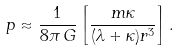<formula> <loc_0><loc_0><loc_500><loc_500>p \approx \frac { 1 } { 8 \pi \, G } \left [ \frac { m \kappa } { ( \lambda + \kappa ) r ^ { 3 } } \right ] .</formula> 